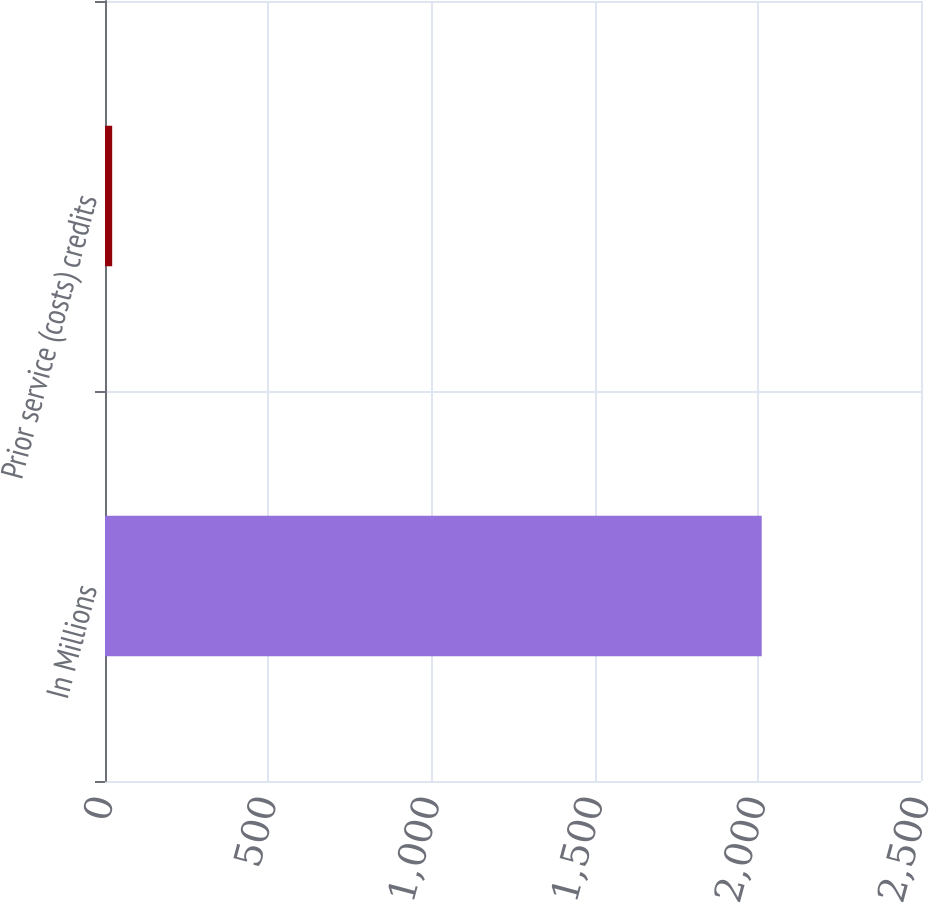<chart> <loc_0><loc_0><loc_500><loc_500><bar_chart><fcel>In Millions<fcel>Prior service (costs) credits<nl><fcel>2012<fcel>22<nl></chart> 